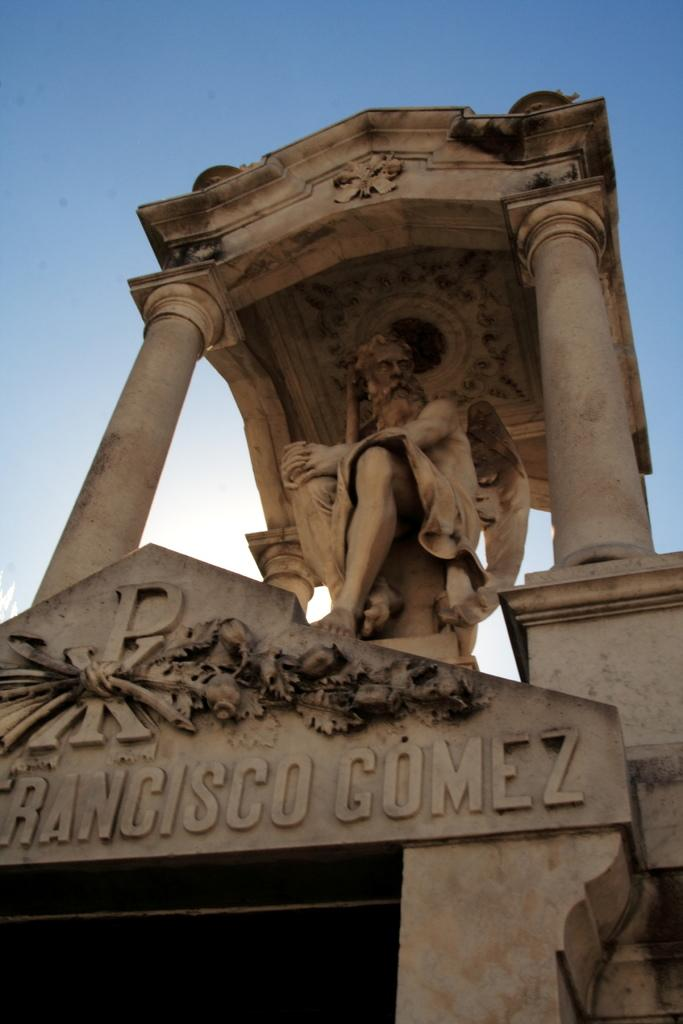What is the main subject of the image? The main subject of the image is a statue of a person. What can be found below the statue? There is something written below the statue. How many clocks are visible on the statue in the image? There are no clocks visible on the statue in the image. 